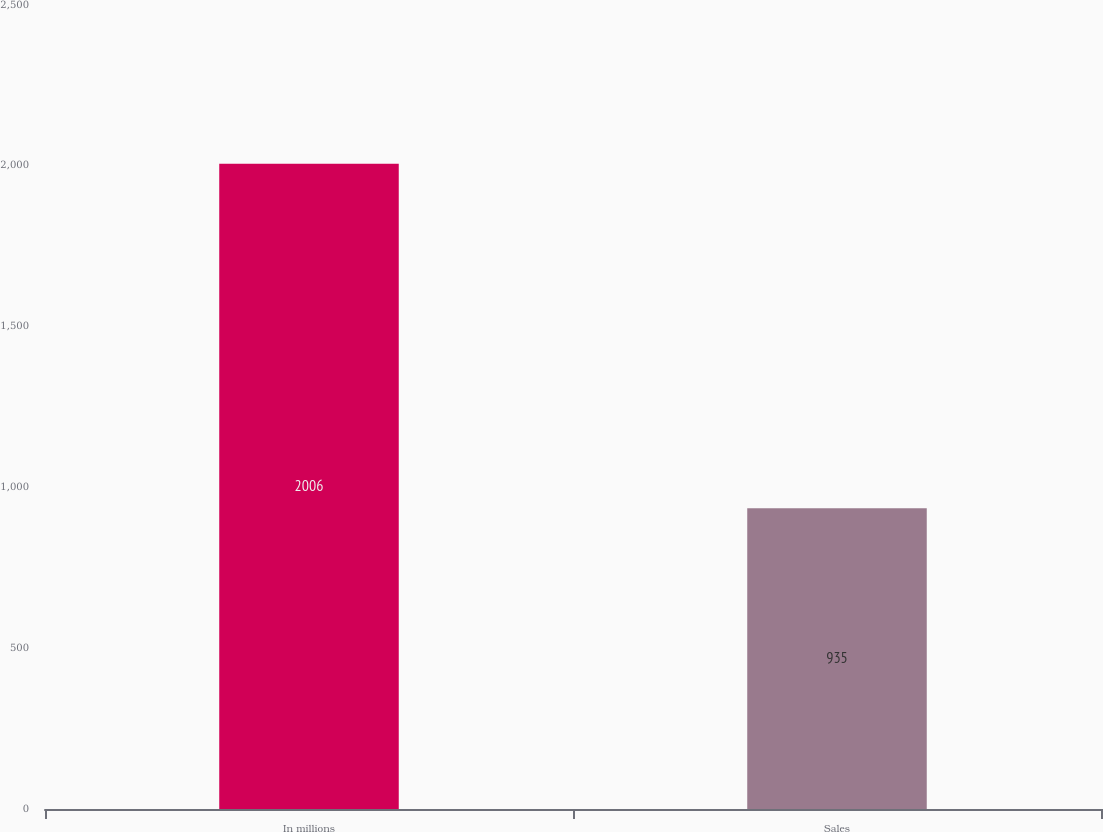Convert chart. <chart><loc_0><loc_0><loc_500><loc_500><bar_chart><fcel>In millions<fcel>Sales<nl><fcel>2006<fcel>935<nl></chart> 